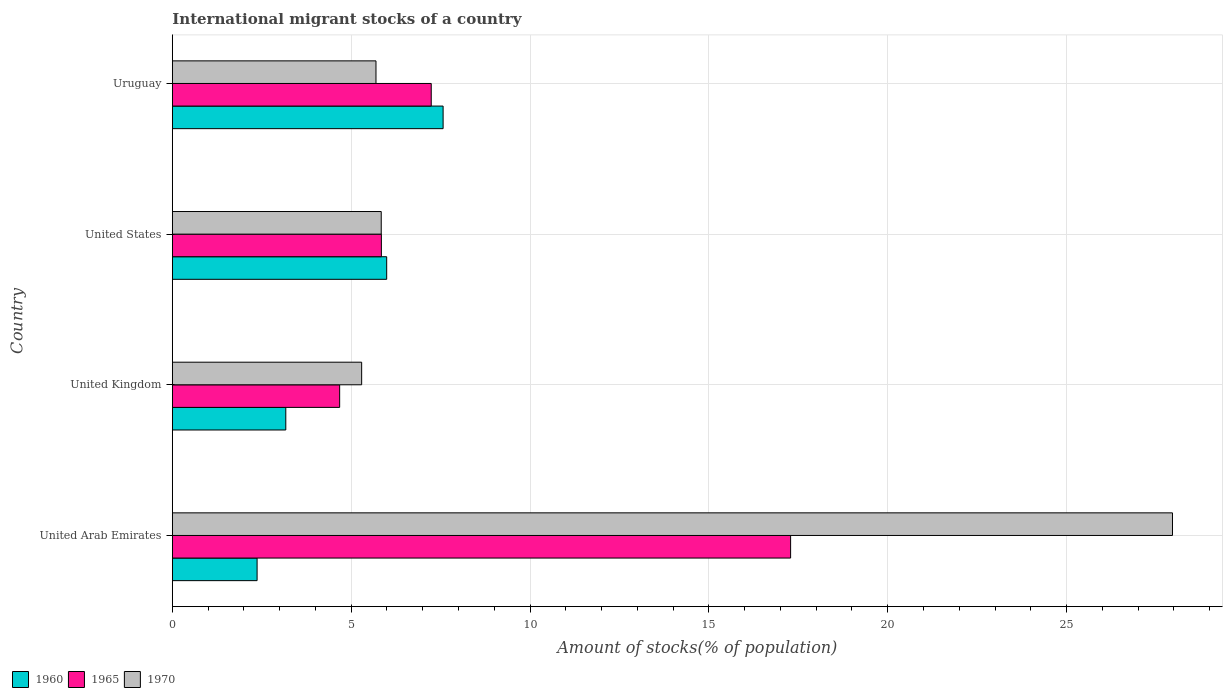How many groups of bars are there?
Your response must be concise. 4. How many bars are there on the 2nd tick from the top?
Your answer should be very brief. 3. How many bars are there on the 4th tick from the bottom?
Offer a very short reply. 3. What is the label of the 1st group of bars from the top?
Provide a short and direct response. Uruguay. What is the amount of stocks in in 1960 in United Arab Emirates?
Keep it short and to the point. 2.37. Across all countries, what is the maximum amount of stocks in in 1970?
Your answer should be compact. 27.96. Across all countries, what is the minimum amount of stocks in in 1965?
Provide a succinct answer. 4.68. In which country was the amount of stocks in in 1965 maximum?
Offer a very short reply. United Arab Emirates. In which country was the amount of stocks in in 1965 minimum?
Ensure brevity in your answer.  United Kingdom. What is the total amount of stocks in in 1970 in the graph?
Give a very brief answer. 44.78. What is the difference between the amount of stocks in in 1965 in United States and that in Uruguay?
Provide a short and direct response. -1.39. What is the difference between the amount of stocks in in 1970 in United Arab Emirates and the amount of stocks in in 1960 in Uruguay?
Keep it short and to the point. 20.39. What is the average amount of stocks in in 1970 per country?
Your response must be concise. 11.2. What is the difference between the amount of stocks in in 1970 and amount of stocks in in 1965 in United Arab Emirates?
Your answer should be very brief. 10.68. In how many countries, is the amount of stocks in in 1970 greater than 5 %?
Keep it short and to the point. 4. What is the ratio of the amount of stocks in in 1965 in United States to that in Uruguay?
Offer a very short reply. 0.81. Is the difference between the amount of stocks in in 1970 in United States and Uruguay greater than the difference between the amount of stocks in in 1965 in United States and Uruguay?
Ensure brevity in your answer.  Yes. What is the difference between the highest and the second highest amount of stocks in in 1960?
Provide a short and direct response. 1.58. What is the difference between the highest and the lowest amount of stocks in in 1960?
Provide a succinct answer. 5.2. In how many countries, is the amount of stocks in in 1960 greater than the average amount of stocks in in 1960 taken over all countries?
Your answer should be very brief. 2. What does the 3rd bar from the bottom in United Arab Emirates represents?
Give a very brief answer. 1970. Are the values on the major ticks of X-axis written in scientific E-notation?
Give a very brief answer. No. How are the legend labels stacked?
Your answer should be compact. Horizontal. What is the title of the graph?
Provide a succinct answer. International migrant stocks of a country. Does "1993" appear as one of the legend labels in the graph?
Make the answer very short. No. What is the label or title of the X-axis?
Provide a succinct answer. Amount of stocks(% of population). What is the Amount of stocks(% of population) of 1960 in United Arab Emirates?
Give a very brief answer. 2.37. What is the Amount of stocks(% of population) in 1965 in United Arab Emirates?
Offer a very short reply. 17.28. What is the Amount of stocks(% of population) in 1970 in United Arab Emirates?
Provide a succinct answer. 27.96. What is the Amount of stocks(% of population) of 1960 in United Kingdom?
Provide a succinct answer. 3.17. What is the Amount of stocks(% of population) of 1965 in United Kingdom?
Make the answer very short. 4.68. What is the Amount of stocks(% of population) of 1970 in United Kingdom?
Give a very brief answer. 5.29. What is the Amount of stocks(% of population) of 1960 in United States?
Offer a terse response. 5.99. What is the Amount of stocks(% of population) of 1965 in United States?
Offer a terse response. 5.84. What is the Amount of stocks(% of population) in 1970 in United States?
Give a very brief answer. 5.84. What is the Amount of stocks(% of population) of 1960 in Uruguay?
Offer a terse response. 7.57. What is the Amount of stocks(% of population) of 1965 in Uruguay?
Ensure brevity in your answer.  7.24. What is the Amount of stocks(% of population) in 1970 in Uruguay?
Make the answer very short. 5.69. Across all countries, what is the maximum Amount of stocks(% of population) of 1960?
Keep it short and to the point. 7.57. Across all countries, what is the maximum Amount of stocks(% of population) of 1965?
Keep it short and to the point. 17.28. Across all countries, what is the maximum Amount of stocks(% of population) in 1970?
Give a very brief answer. 27.96. Across all countries, what is the minimum Amount of stocks(% of population) in 1960?
Keep it short and to the point. 2.37. Across all countries, what is the minimum Amount of stocks(% of population) in 1965?
Provide a succinct answer. 4.68. Across all countries, what is the minimum Amount of stocks(% of population) in 1970?
Ensure brevity in your answer.  5.29. What is the total Amount of stocks(% of population) of 1960 in the graph?
Keep it short and to the point. 19.1. What is the total Amount of stocks(% of population) in 1965 in the graph?
Your response must be concise. 35.04. What is the total Amount of stocks(% of population) of 1970 in the graph?
Provide a succinct answer. 44.78. What is the difference between the Amount of stocks(% of population) in 1960 in United Arab Emirates and that in United Kingdom?
Give a very brief answer. -0.8. What is the difference between the Amount of stocks(% of population) in 1965 in United Arab Emirates and that in United Kingdom?
Make the answer very short. 12.61. What is the difference between the Amount of stocks(% of population) in 1970 in United Arab Emirates and that in United Kingdom?
Your response must be concise. 22.67. What is the difference between the Amount of stocks(% of population) of 1960 in United Arab Emirates and that in United States?
Make the answer very short. -3.62. What is the difference between the Amount of stocks(% of population) in 1965 in United Arab Emirates and that in United States?
Your answer should be very brief. 11.44. What is the difference between the Amount of stocks(% of population) in 1970 in United Arab Emirates and that in United States?
Ensure brevity in your answer.  22.12. What is the difference between the Amount of stocks(% of population) in 1960 in United Arab Emirates and that in Uruguay?
Provide a succinct answer. -5.2. What is the difference between the Amount of stocks(% of population) of 1965 in United Arab Emirates and that in Uruguay?
Your response must be concise. 10.05. What is the difference between the Amount of stocks(% of population) of 1970 in United Arab Emirates and that in Uruguay?
Offer a terse response. 22.27. What is the difference between the Amount of stocks(% of population) in 1960 in United Kingdom and that in United States?
Provide a short and direct response. -2.82. What is the difference between the Amount of stocks(% of population) in 1965 in United Kingdom and that in United States?
Offer a very short reply. -1.17. What is the difference between the Amount of stocks(% of population) in 1970 in United Kingdom and that in United States?
Give a very brief answer. -0.55. What is the difference between the Amount of stocks(% of population) of 1960 in United Kingdom and that in Uruguay?
Provide a short and direct response. -4.4. What is the difference between the Amount of stocks(% of population) in 1965 in United Kingdom and that in Uruguay?
Your response must be concise. -2.56. What is the difference between the Amount of stocks(% of population) in 1970 in United Kingdom and that in Uruguay?
Keep it short and to the point. -0.4. What is the difference between the Amount of stocks(% of population) in 1960 in United States and that in Uruguay?
Provide a short and direct response. -1.58. What is the difference between the Amount of stocks(% of population) in 1965 in United States and that in Uruguay?
Provide a short and direct response. -1.39. What is the difference between the Amount of stocks(% of population) of 1970 in United States and that in Uruguay?
Offer a terse response. 0.15. What is the difference between the Amount of stocks(% of population) in 1960 in United Arab Emirates and the Amount of stocks(% of population) in 1965 in United Kingdom?
Provide a short and direct response. -2.31. What is the difference between the Amount of stocks(% of population) in 1960 in United Arab Emirates and the Amount of stocks(% of population) in 1970 in United Kingdom?
Offer a very short reply. -2.92. What is the difference between the Amount of stocks(% of population) in 1965 in United Arab Emirates and the Amount of stocks(% of population) in 1970 in United Kingdom?
Your response must be concise. 11.99. What is the difference between the Amount of stocks(% of population) of 1960 in United Arab Emirates and the Amount of stocks(% of population) of 1965 in United States?
Offer a terse response. -3.47. What is the difference between the Amount of stocks(% of population) of 1960 in United Arab Emirates and the Amount of stocks(% of population) of 1970 in United States?
Provide a short and direct response. -3.47. What is the difference between the Amount of stocks(% of population) of 1965 in United Arab Emirates and the Amount of stocks(% of population) of 1970 in United States?
Provide a succinct answer. 11.44. What is the difference between the Amount of stocks(% of population) in 1960 in United Arab Emirates and the Amount of stocks(% of population) in 1965 in Uruguay?
Give a very brief answer. -4.87. What is the difference between the Amount of stocks(% of population) of 1960 in United Arab Emirates and the Amount of stocks(% of population) of 1970 in Uruguay?
Give a very brief answer. -3.32. What is the difference between the Amount of stocks(% of population) of 1965 in United Arab Emirates and the Amount of stocks(% of population) of 1970 in Uruguay?
Provide a succinct answer. 11.59. What is the difference between the Amount of stocks(% of population) of 1960 in United Kingdom and the Amount of stocks(% of population) of 1965 in United States?
Your answer should be compact. -2.67. What is the difference between the Amount of stocks(% of population) of 1960 in United Kingdom and the Amount of stocks(% of population) of 1970 in United States?
Keep it short and to the point. -2.67. What is the difference between the Amount of stocks(% of population) of 1965 in United Kingdom and the Amount of stocks(% of population) of 1970 in United States?
Your answer should be very brief. -1.16. What is the difference between the Amount of stocks(% of population) of 1960 in United Kingdom and the Amount of stocks(% of population) of 1965 in Uruguay?
Your response must be concise. -4.07. What is the difference between the Amount of stocks(% of population) of 1960 in United Kingdom and the Amount of stocks(% of population) of 1970 in Uruguay?
Your response must be concise. -2.52. What is the difference between the Amount of stocks(% of population) of 1965 in United Kingdom and the Amount of stocks(% of population) of 1970 in Uruguay?
Your answer should be compact. -1.02. What is the difference between the Amount of stocks(% of population) of 1960 in United States and the Amount of stocks(% of population) of 1965 in Uruguay?
Offer a very short reply. -1.25. What is the difference between the Amount of stocks(% of population) of 1960 in United States and the Amount of stocks(% of population) of 1970 in Uruguay?
Provide a succinct answer. 0.3. What is the difference between the Amount of stocks(% of population) of 1965 in United States and the Amount of stocks(% of population) of 1970 in Uruguay?
Your response must be concise. 0.15. What is the average Amount of stocks(% of population) in 1960 per country?
Your answer should be compact. 4.78. What is the average Amount of stocks(% of population) of 1965 per country?
Your response must be concise. 8.76. What is the average Amount of stocks(% of population) of 1970 per country?
Your answer should be very brief. 11.2. What is the difference between the Amount of stocks(% of population) of 1960 and Amount of stocks(% of population) of 1965 in United Arab Emirates?
Provide a short and direct response. -14.91. What is the difference between the Amount of stocks(% of population) of 1960 and Amount of stocks(% of population) of 1970 in United Arab Emirates?
Make the answer very short. -25.59. What is the difference between the Amount of stocks(% of population) of 1965 and Amount of stocks(% of population) of 1970 in United Arab Emirates?
Ensure brevity in your answer.  -10.68. What is the difference between the Amount of stocks(% of population) of 1960 and Amount of stocks(% of population) of 1965 in United Kingdom?
Your answer should be very brief. -1.51. What is the difference between the Amount of stocks(% of population) in 1960 and Amount of stocks(% of population) in 1970 in United Kingdom?
Ensure brevity in your answer.  -2.12. What is the difference between the Amount of stocks(% of population) in 1965 and Amount of stocks(% of population) in 1970 in United Kingdom?
Your response must be concise. -0.62. What is the difference between the Amount of stocks(% of population) in 1960 and Amount of stocks(% of population) in 1965 in United States?
Provide a succinct answer. 0.15. What is the difference between the Amount of stocks(% of population) of 1960 and Amount of stocks(% of population) of 1970 in United States?
Give a very brief answer. 0.15. What is the difference between the Amount of stocks(% of population) of 1965 and Amount of stocks(% of population) of 1970 in United States?
Make the answer very short. 0. What is the difference between the Amount of stocks(% of population) of 1960 and Amount of stocks(% of population) of 1965 in Uruguay?
Offer a terse response. 0.33. What is the difference between the Amount of stocks(% of population) in 1960 and Amount of stocks(% of population) in 1970 in Uruguay?
Provide a short and direct response. 1.88. What is the difference between the Amount of stocks(% of population) of 1965 and Amount of stocks(% of population) of 1970 in Uruguay?
Give a very brief answer. 1.54. What is the ratio of the Amount of stocks(% of population) in 1960 in United Arab Emirates to that in United Kingdom?
Provide a short and direct response. 0.75. What is the ratio of the Amount of stocks(% of population) in 1965 in United Arab Emirates to that in United Kingdom?
Keep it short and to the point. 3.7. What is the ratio of the Amount of stocks(% of population) of 1970 in United Arab Emirates to that in United Kingdom?
Make the answer very short. 5.28. What is the ratio of the Amount of stocks(% of population) of 1960 in United Arab Emirates to that in United States?
Offer a very short reply. 0.4. What is the ratio of the Amount of stocks(% of population) in 1965 in United Arab Emirates to that in United States?
Provide a succinct answer. 2.96. What is the ratio of the Amount of stocks(% of population) in 1970 in United Arab Emirates to that in United States?
Provide a succinct answer. 4.79. What is the ratio of the Amount of stocks(% of population) of 1960 in United Arab Emirates to that in Uruguay?
Provide a succinct answer. 0.31. What is the ratio of the Amount of stocks(% of population) in 1965 in United Arab Emirates to that in Uruguay?
Keep it short and to the point. 2.39. What is the ratio of the Amount of stocks(% of population) in 1970 in United Arab Emirates to that in Uruguay?
Offer a very short reply. 4.91. What is the ratio of the Amount of stocks(% of population) of 1960 in United Kingdom to that in United States?
Ensure brevity in your answer.  0.53. What is the ratio of the Amount of stocks(% of population) in 1965 in United Kingdom to that in United States?
Offer a terse response. 0.8. What is the ratio of the Amount of stocks(% of population) of 1970 in United Kingdom to that in United States?
Make the answer very short. 0.91. What is the ratio of the Amount of stocks(% of population) of 1960 in United Kingdom to that in Uruguay?
Ensure brevity in your answer.  0.42. What is the ratio of the Amount of stocks(% of population) in 1965 in United Kingdom to that in Uruguay?
Keep it short and to the point. 0.65. What is the ratio of the Amount of stocks(% of population) in 1970 in United Kingdom to that in Uruguay?
Your answer should be compact. 0.93. What is the ratio of the Amount of stocks(% of population) of 1960 in United States to that in Uruguay?
Offer a very short reply. 0.79. What is the ratio of the Amount of stocks(% of population) in 1965 in United States to that in Uruguay?
Keep it short and to the point. 0.81. What is the ratio of the Amount of stocks(% of population) in 1970 in United States to that in Uruguay?
Provide a short and direct response. 1.03. What is the difference between the highest and the second highest Amount of stocks(% of population) in 1960?
Provide a succinct answer. 1.58. What is the difference between the highest and the second highest Amount of stocks(% of population) in 1965?
Offer a terse response. 10.05. What is the difference between the highest and the second highest Amount of stocks(% of population) in 1970?
Ensure brevity in your answer.  22.12. What is the difference between the highest and the lowest Amount of stocks(% of population) in 1960?
Provide a short and direct response. 5.2. What is the difference between the highest and the lowest Amount of stocks(% of population) in 1965?
Make the answer very short. 12.61. What is the difference between the highest and the lowest Amount of stocks(% of population) of 1970?
Your answer should be compact. 22.67. 